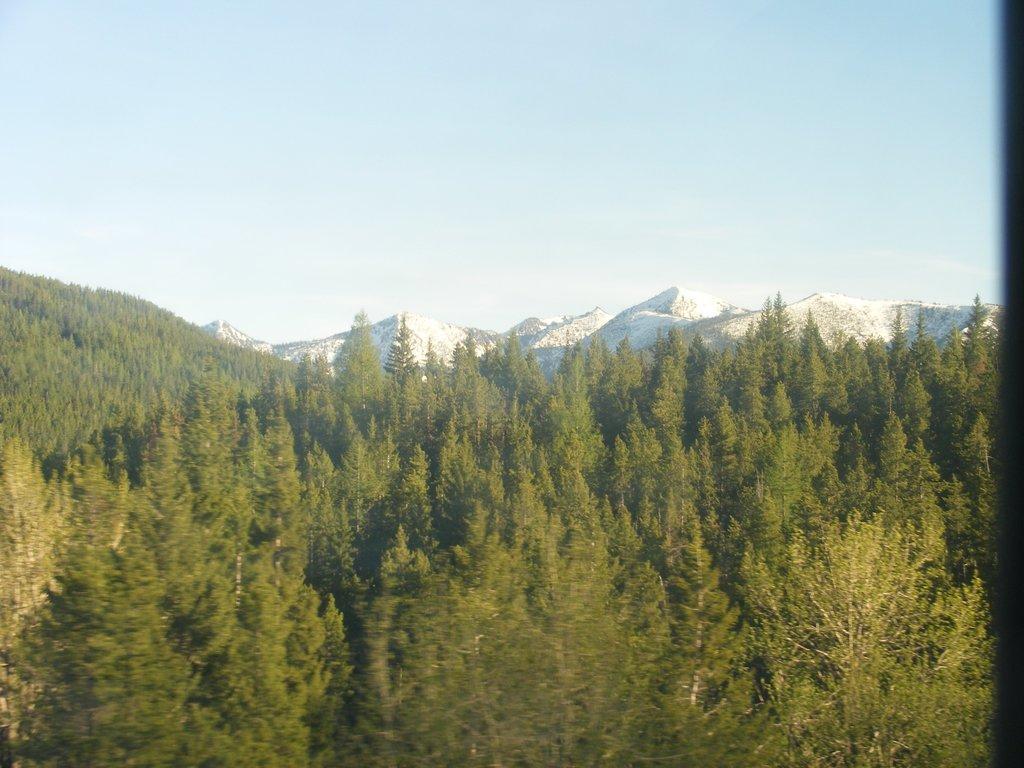In one or two sentences, can you explain what this image depicts? In this image we can see sky, mountains and trees. 